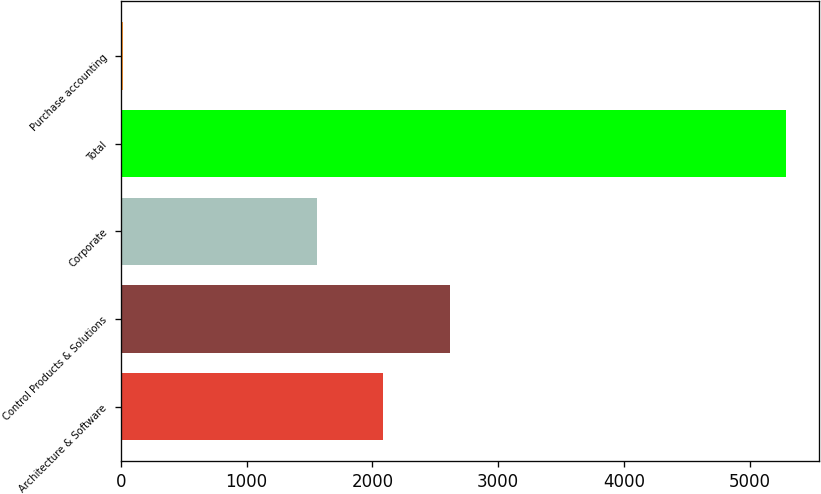Convert chart to OTSL. <chart><loc_0><loc_0><loc_500><loc_500><bar_chart><fcel>Architecture & Software<fcel>Control Products & Solutions<fcel>Corporate<fcel>Total<fcel>Purchase accounting<nl><fcel>2086.91<fcel>2613.42<fcel>1560.4<fcel>5284.9<fcel>19.8<nl></chart> 